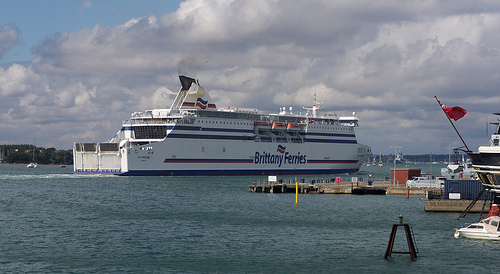Please provide the bounding box coordinate of the region this sentence describes: Calm blue water. The bounding box coordinates for the calm blue water are [0.09, 0.59, 0.53, 0.74]. 